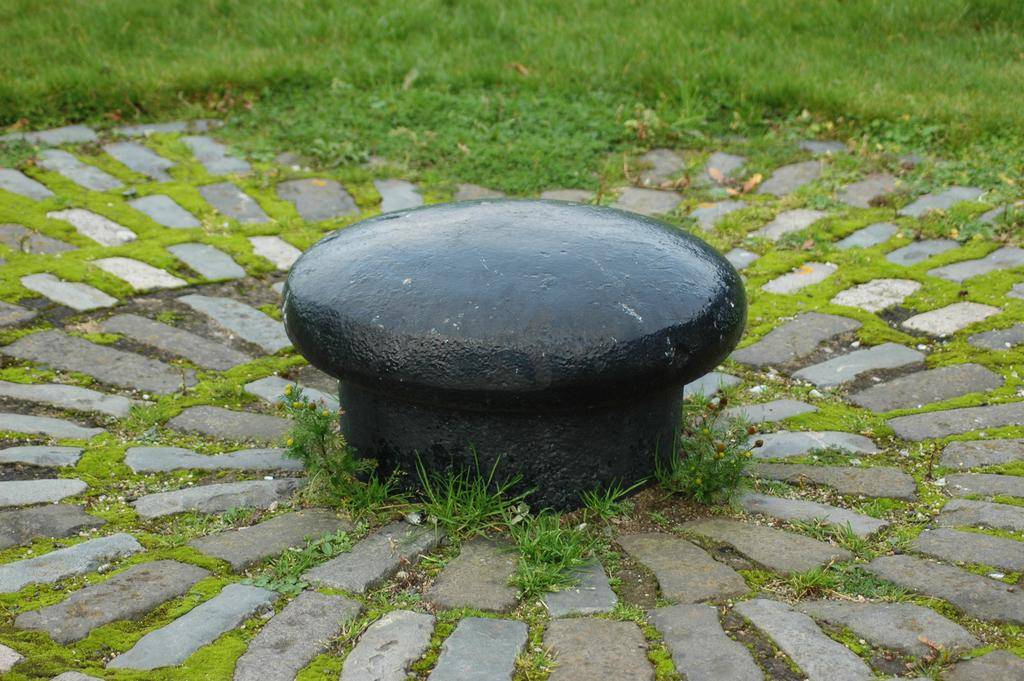What is the main subject of the image? The main subject of the image is a rock structure. Where is the rock structure located in the image? The rock structure is at the center of the image. What surrounds the rock structure in the image? The rock structure is surrounded by rocks and grass. What type of oatmeal can be seen in the nest at the top of the rock structure? There is no oatmeal or nest present in the image; it features a rock structure surrounded by rocks and grass. 